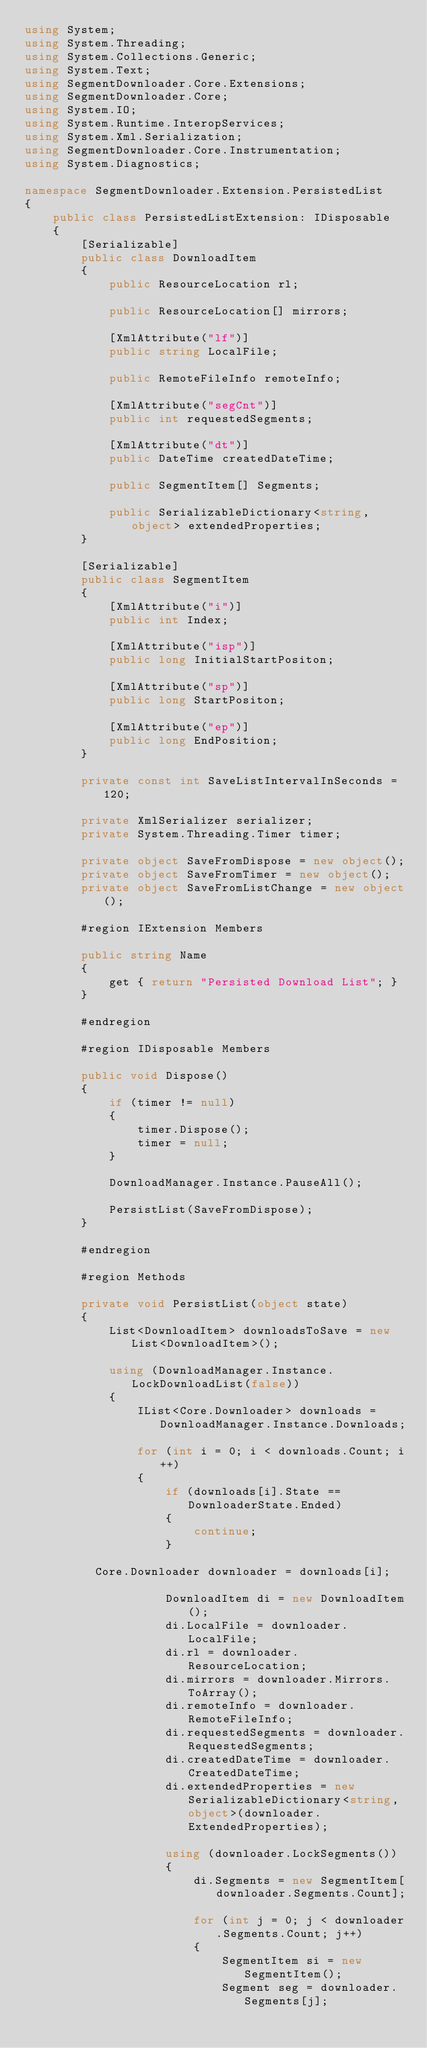<code> <loc_0><loc_0><loc_500><loc_500><_C#_>using System;
using System.Threading;
using System.Collections.Generic;
using System.Text;
using SegmentDownloader.Core.Extensions;
using SegmentDownloader.Core;
using System.IO;
using System.Runtime.InteropServices;
using System.Xml.Serialization;
using SegmentDownloader.Core.Instrumentation;
using System.Diagnostics;

namespace SegmentDownloader.Extension.PersistedList
{
    public class PersistedListExtension: IDisposable
    {
        [Serializable]
        public class DownloadItem
        {
            public ResourceLocation rl;

            public ResourceLocation[] mirrors;

            [XmlAttribute("lf")]
            public string LocalFile;

            public RemoteFileInfo remoteInfo;

            [XmlAttribute("segCnt")]
            public int requestedSegments;

            [XmlAttribute("dt")]
            public DateTime createdDateTime;

            public SegmentItem[] Segments;

            public SerializableDictionary<string, object> extendedProperties;
        }

        [Serializable]
        public class SegmentItem
        {
            [XmlAttribute("i")]
            public int Index;

            [XmlAttribute("isp")]
            public long InitialStartPositon;

            [XmlAttribute("sp")]
            public long StartPositon;

            [XmlAttribute("ep")]
            public long EndPosition;
        }

        private const int SaveListIntervalInSeconds = 120;

        private XmlSerializer serializer;
        private System.Threading.Timer timer;

        private object SaveFromDispose = new object();
        private object SaveFromTimer = new object();
        private object SaveFromListChange = new object();

        #region IExtension Members

        public string Name
        {
            get { return "Persisted Download List"; }
        }

        #endregion

        #region IDisposable Members

        public void Dispose()
        {
            if (timer != null)
            {
                timer.Dispose();
                timer = null;
            }

            DownloadManager.Instance.PauseAll();

            PersistList(SaveFromDispose);
        }

        #endregion

        #region Methods

        private void PersistList(object state)
        {
            List<DownloadItem> downloadsToSave = new List<DownloadItem>();

            using (DownloadManager.Instance.LockDownloadList(false))
            {
                IList<Core.Downloader> downloads = DownloadManager.Instance.Downloads;

                for (int i = 0; i < downloads.Count; i++)
                {
                    if (downloads[i].State == DownloaderState.Ended)
                    {
                        continue;
                    }

					Core.Downloader downloader = downloads[i];

                    DownloadItem di = new DownloadItem();
                    di.LocalFile = downloader.LocalFile;
                    di.rl = downloader.ResourceLocation;
                    di.mirrors = downloader.Mirrors.ToArray();
                    di.remoteInfo = downloader.RemoteFileInfo;
                    di.requestedSegments = downloader.RequestedSegments;
                    di.createdDateTime = downloader.CreatedDateTime;
                    di.extendedProperties = new SerializableDictionary<string,object>(downloader.ExtendedProperties);

                    using (downloader.LockSegments())
                    {
                        di.Segments = new SegmentItem[downloader.Segments.Count];

                        for (int j = 0; j < downloader.Segments.Count; j++)
                        {
                            SegmentItem si = new SegmentItem();
                            Segment seg = downloader.Segments[j];
</code> 